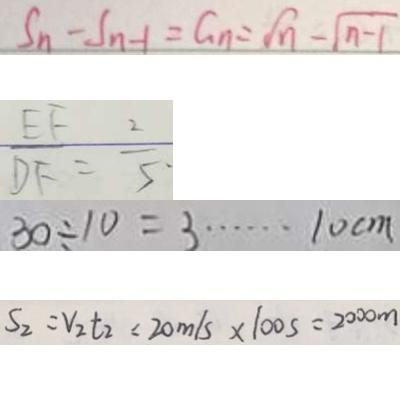Convert formula to latex. <formula><loc_0><loc_0><loc_500><loc_500>S _ { n } - S _ { n - 1 } = G _ { n } = \sqrt { n } - \sqrt { n - 1 } 
 \frac { E F } { D F } = \frac { 2 } { 5 } \cdot 
 3 0 \div 1 0 = 3 \cdots 1 0 c m 
 S _ { 2 } = V _ { 2 } t _ { 2 } = 2 0 m / s \times 1 0 0 s = 2 0 0 0 m</formula> 